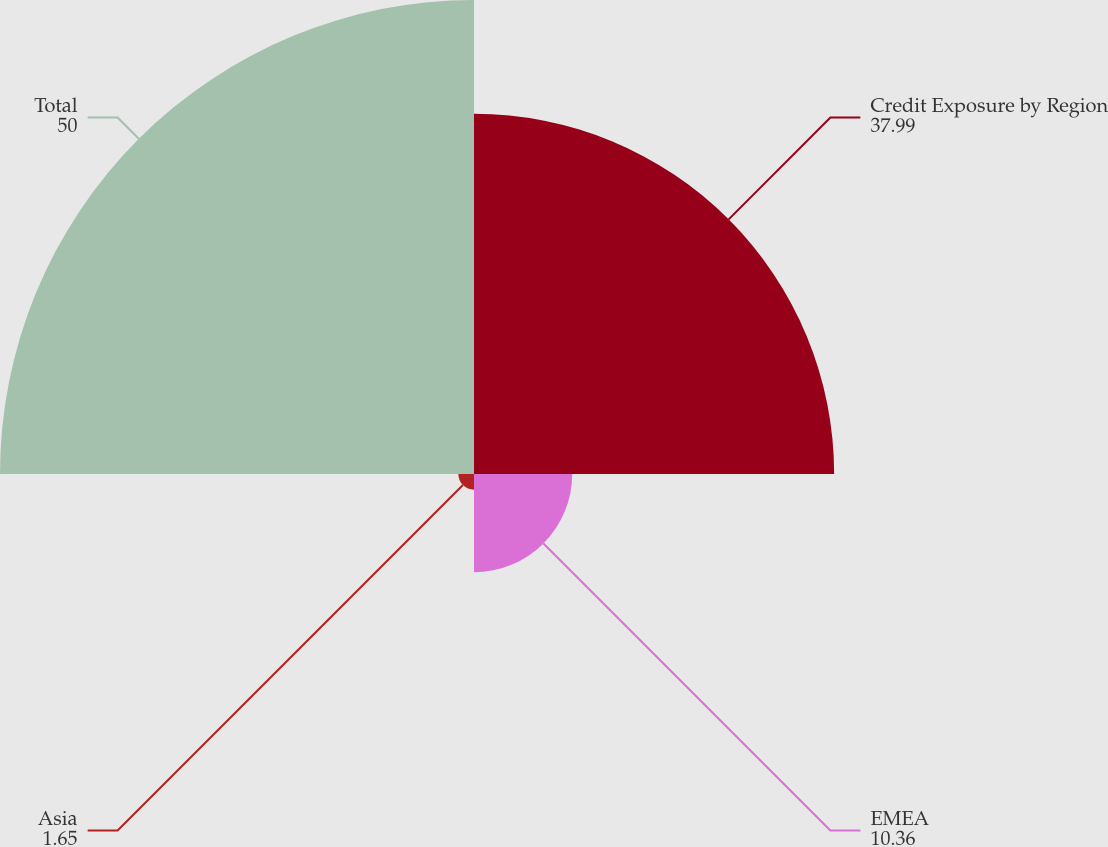Convert chart to OTSL. <chart><loc_0><loc_0><loc_500><loc_500><pie_chart><fcel>Credit Exposure by Region<fcel>EMEA<fcel>Asia<fcel>Total<nl><fcel>37.99%<fcel>10.36%<fcel>1.65%<fcel>50.0%<nl></chart> 